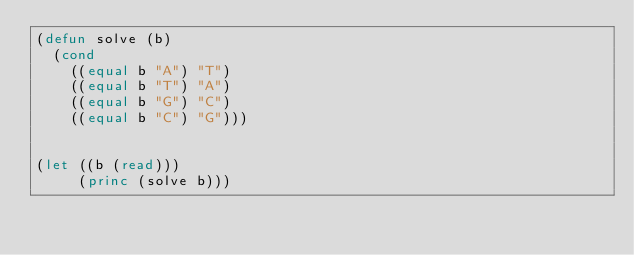<code> <loc_0><loc_0><loc_500><loc_500><_Lisp_>(defun solve (b)
  (cond
    ((equal b "A") "T")
    ((equal b "T") "A")
    ((equal b "G") "C")
    ((equal b "C") "G")))


(let ((b (read)))
     (princ (solve b)))</code> 